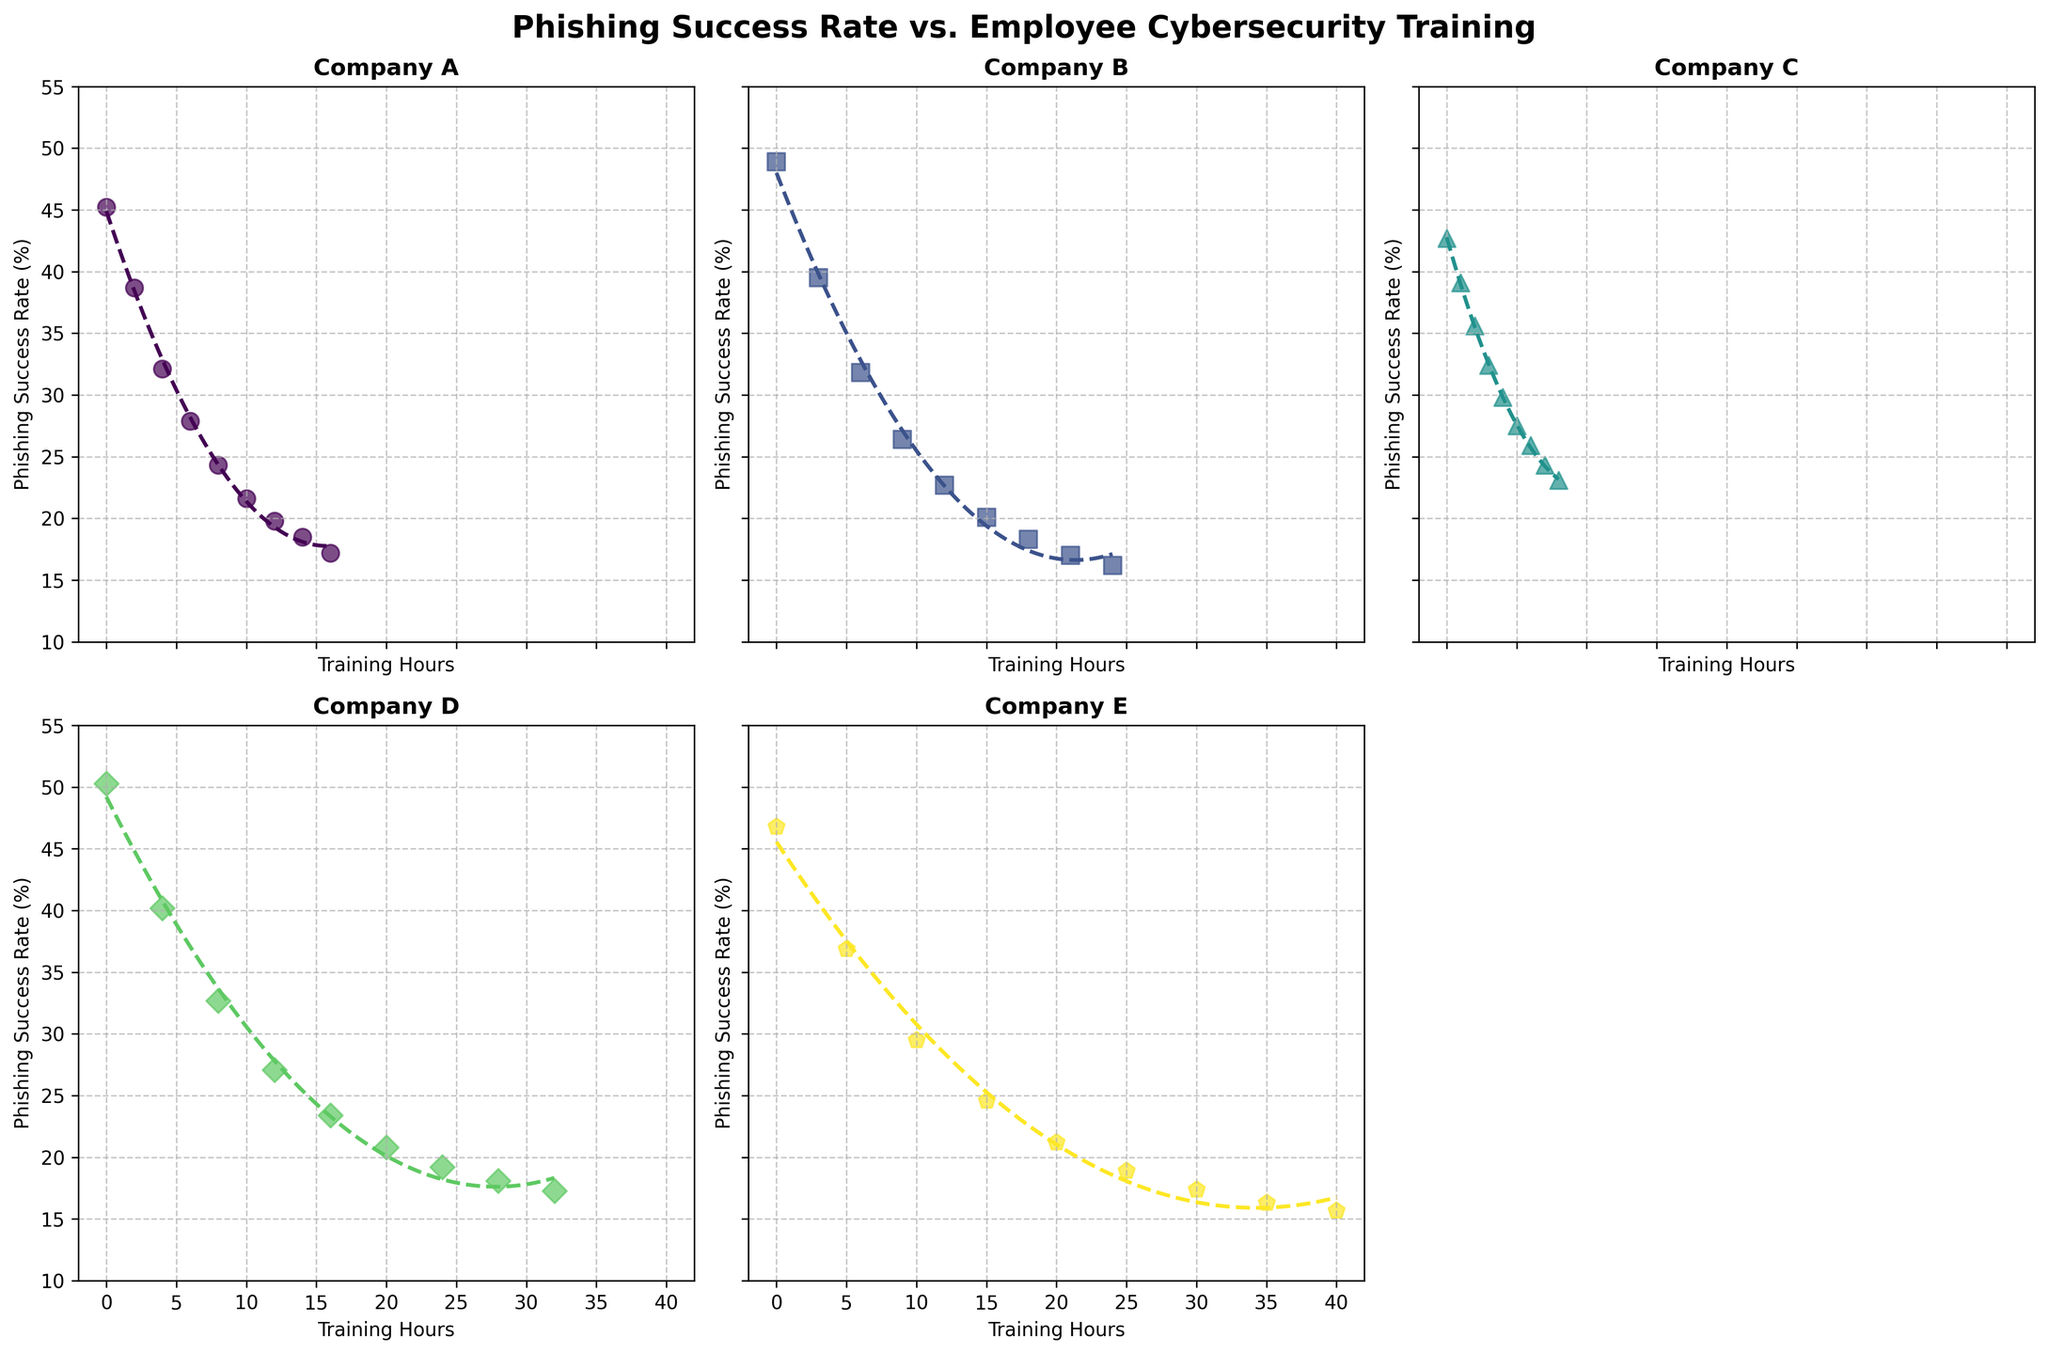How does the phishing success rate for Company A change as training hours increase? The plot for Company A shows a downward trend in phishing success rates as training hours increase. By observing the scatter points and the fitted curve, it's evident that more training hours result in lower phishing success rates. Starting from about 45.2% with 0 hours of training, the success rate drops to approximately 17.2% at 16 hours of training.
Answer: The phishing success rate decreases How do the phishing success rates of Company B and Company C at 6 training hours compare? For Company B at 6 training hours, the phishing success rate is 31.8%, while for Company C at the same number of training hours, the phishing success rate is 25.9%. By comparing these values from their respective scatter plots, we can conclude that Company C has a lower phishing success rate than Company B at 6 training hours.
Answer: Company C has a lower rate Which company shows the least reduction in phishing success rates with increasing training hours? Among all companies, Company C shows the least reduction in phishing success rates with increasing training hours. Starting close to 42.7% at 0 hours and ending at approximately 23.1% with 8 hours of training, the rate decrease is relatively smaller compared to the other companies whose rates decrease significantly.
Answer: Company C What are the phishing success rates for Company D at 0 training hours and 32 training hours? The scatter plot for Company D indicates that at 0 training hours, the phishing success rate is 50.3%, and at 32 training hours, the success rate reduces to 17.3%. Both these points are directly visible from the scatter plot for Company D.
Answer: 50.3% at 0 hours, 17.3% at 32 hours Which company achieves a phishing success rate below 20% with the fewest training hours? By examining the scatter plots and fit curves for each company, Company E achieves a phishing success rate below 20% with the fewest training hours. This occurs with 20 hours of training, at which point the success rate is 18.9%. This is lower than the corresponding times and rates for other companies.
Answer: Company E with 20 hours Is there a point at which the phishing success rate of Company A falls below 20%? If so, after how many training hours? By looking at the scatter plot and the fit curve for Company A, the phishing success rate falls below 20% after approximately 12 hours of training. Beyond 12 hours, the success rate continues to decrease further below the 20% mark.
Answer: Yes, after 12 hours Compare the initial phishing success rates (at 0 training hours) of all companies – which company has the highest initial rate? Reviewing the scatter points for each company's plot at 0 training hours, the initial phishing success rates are: Company A – 45.2%, Company B – 48.9%, Company C – 42.7%, Company D – 50.3%, and Company E – 46.8%. The highest initial rate is for Company D, at 50.3%.
Answer: Company D with 50.3% What trend is suggested by the scatter plot and fitted curve of Company E? The scatter plot and fitted curve for Company E suggest a clear downward trend in phishing success rates as the training hours increase. The phishing success rate starts high at 46.8% with 0 training hours and decreases steadily to about 15.7% at 40 hours of training, showing a significant improvement with more training.
Answer: A downward trend For company B, which training hour markers are associated with a phishing success rate above 30%? For Company B, based on the scatter plot, the phishing success rates above 30% are associated with 0, 3, and 6 training hours. Specifically, rates are 48.9% at 0 hours, 39.5% at 3 hours, and 31.8% at 6 hours. These markers can be identified visually.
Answer: 0, 3, and 6 hours Compare the highest and lowest phishing success rates for Company D. What is the difference between these rates? In the scatter plot for Company D, the highest phishing success rate is at 0 training hours, which is 50.3%, and the lowest rate is at 32 training hours, which is 17.3%. The difference between these rates is calculated as 50.3% - 17.3% = 33%.
Answer: The difference is 33% 